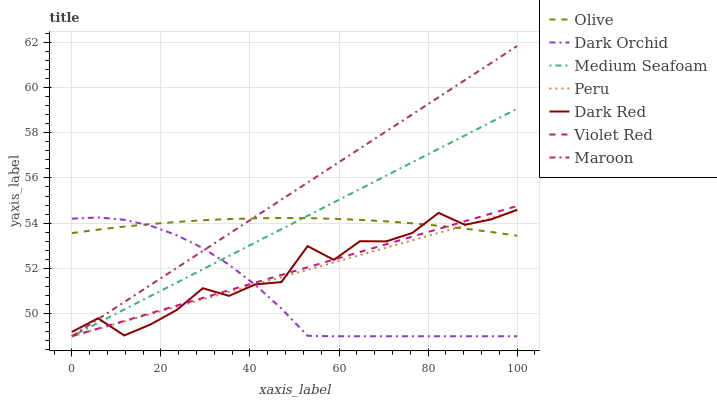Does Dark Orchid have the minimum area under the curve?
Answer yes or no. Yes. Does Maroon have the maximum area under the curve?
Answer yes or no. Yes. Does Dark Red have the minimum area under the curve?
Answer yes or no. No. Does Dark Red have the maximum area under the curve?
Answer yes or no. No. Is Peru the smoothest?
Answer yes or no. Yes. Is Dark Red the roughest?
Answer yes or no. Yes. Is Dark Orchid the smoothest?
Answer yes or no. No. Is Dark Orchid the roughest?
Answer yes or no. No. Does Violet Red have the lowest value?
Answer yes or no. Yes. Does Dark Red have the lowest value?
Answer yes or no. No. Does Maroon have the highest value?
Answer yes or no. Yes. Does Dark Red have the highest value?
Answer yes or no. No. Does Dark Orchid intersect Medium Seafoam?
Answer yes or no. Yes. Is Dark Orchid less than Medium Seafoam?
Answer yes or no. No. Is Dark Orchid greater than Medium Seafoam?
Answer yes or no. No. 